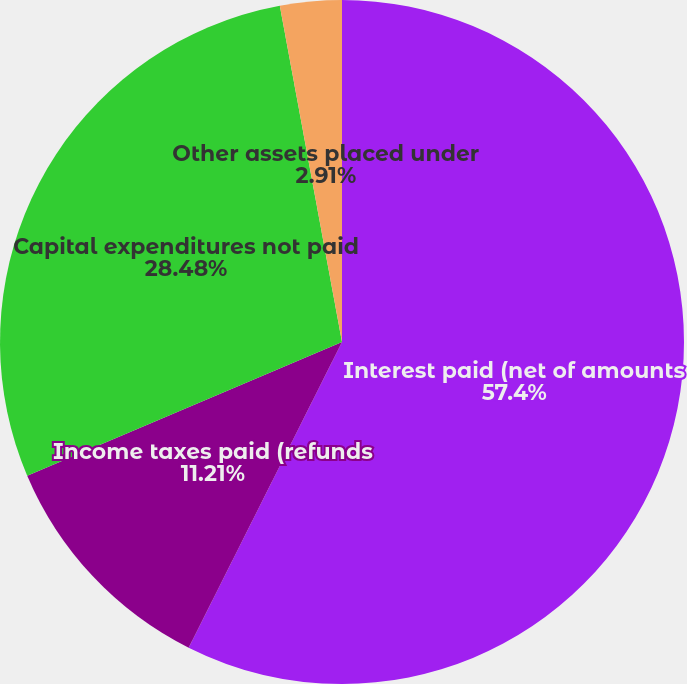Convert chart to OTSL. <chart><loc_0><loc_0><loc_500><loc_500><pie_chart><fcel>Interest paid (net of amounts<fcel>Income taxes paid (refunds<fcel>Capital expenditures not paid<fcel>Other assets placed under<nl><fcel>57.4%<fcel>11.21%<fcel>28.48%<fcel>2.91%<nl></chart> 